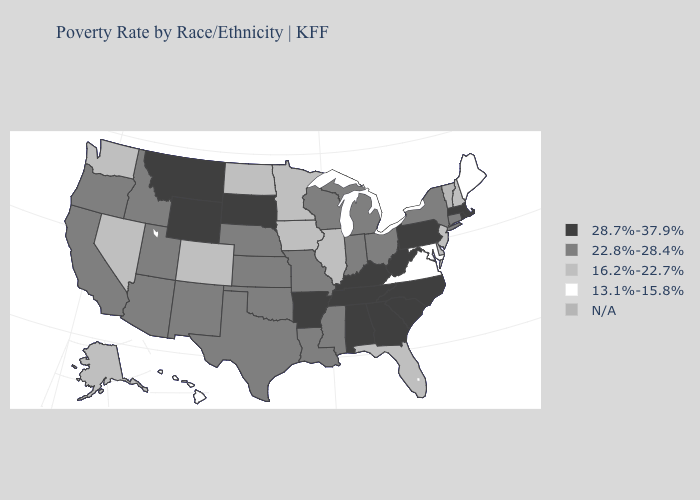Name the states that have a value in the range 13.1%-15.8%?
Keep it brief. Hawaii, Maine, Maryland, Virginia. Does Rhode Island have the lowest value in the Northeast?
Keep it brief. No. What is the value of Kentucky?
Answer briefly. 28.7%-37.9%. Is the legend a continuous bar?
Answer briefly. No. How many symbols are there in the legend?
Write a very short answer. 5. Which states have the lowest value in the USA?
Write a very short answer. Hawaii, Maine, Maryland, Virginia. What is the highest value in the South ?
Short answer required. 28.7%-37.9%. Name the states that have a value in the range N/A?
Give a very brief answer. Vermont. Name the states that have a value in the range 13.1%-15.8%?
Quick response, please. Hawaii, Maine, Maryland, Virginia. What is the value of Wisconsin?
Quick response, please. 22.8%-28.4%. Name the states that have a value in the range N/A?
Answer briefly. Vermont. Which states have the lowest value in the MidWest?
Answer briefly. Illinois, Iowa, Minnesota, North Dakota. What is the value of Minnesota?
Keep it brief. 16.2%-22.7%. 